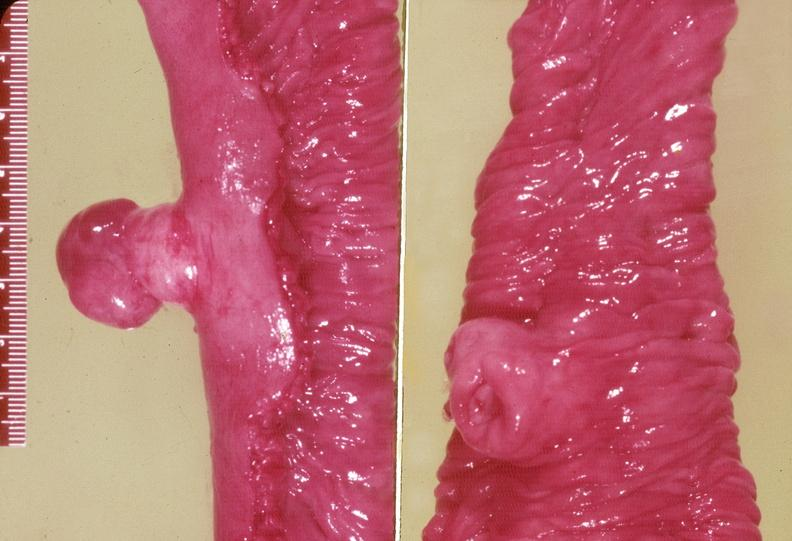what does this image show?
Answer the question using a single word or phrase. Gejunum 